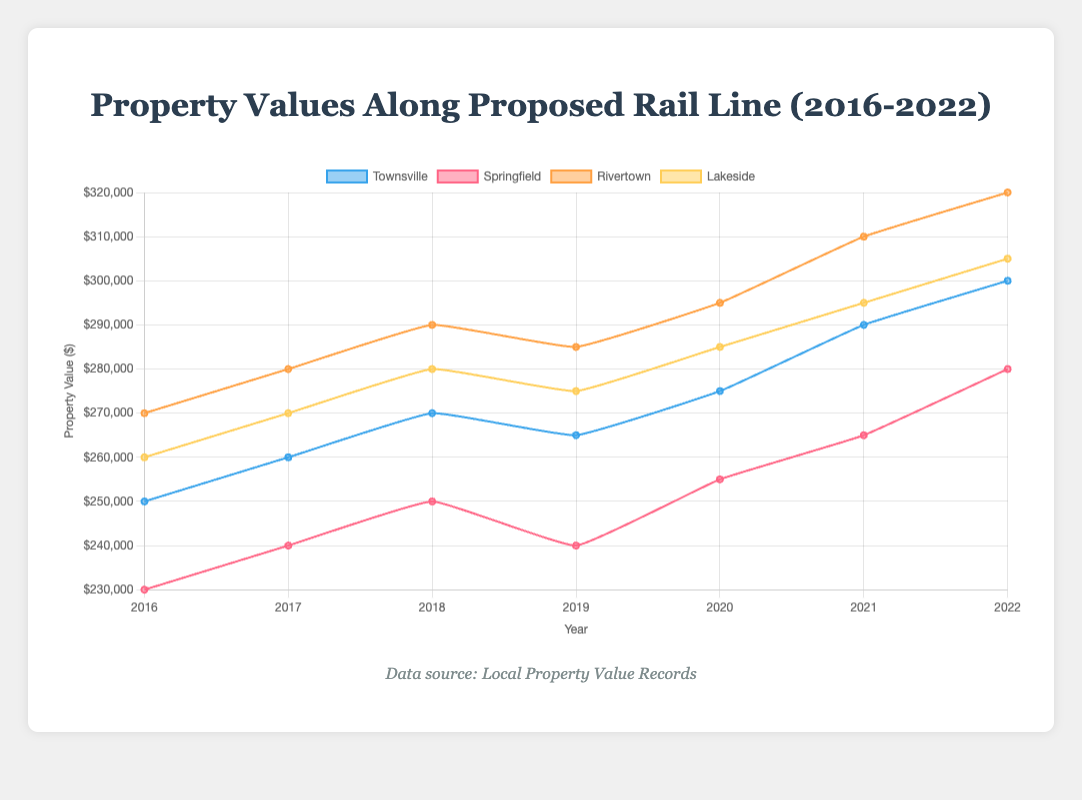What's the average property value in Townsville over the years? To calculate the average, sum the property values in Townsville from 2016 to 2022 (250000 + 260000 + 270000 + 265000 + 275000 + 290000 + 300000 = 1910000) and then divide by the number of years (7). 1910000 / 7 = 273000.
Answer: 273000 Which town experienced the highest property value in 2022? By looking at the property values in 2022 for each town, we can compare: Townsville (300000), Springfield (280000), Rivertown (320000), and Lakeside (305000). Rivertown has the highest property value in 2022.
Answer: Rivertown How did the property values in Springfield change from 2019 to 2020? The property value in Springfield in 2019 is 240000 and in 2020 it is 255000. The change is 255000 - 240000 = 15000. The property values increased by 15000.
Answer: Increased by 15000 In which year did Lakeside's property values decrease compared to the previous year? Cross-referencing Lakeside’s property values for each year: 260000 (2016), 270000 (2017), 280000 (2018), 275000 (2019), 285000 (2020), 295000 (2021), and 305000 (2022), we see that the value from 2018 (280000) to 2019 (275000) decreased by 5000.
Answer: 2019 Compare the property values between Rivertown and Lakeside in 2021. Which one is higher and by how much? In 2021, the property value in Rivertown is 310000 and in Lakeside it is 295000. The difference is 310000 - 295000 = 15000. Rivertown's property value is higher by 15000.
Answer: Rivertown by 15000 